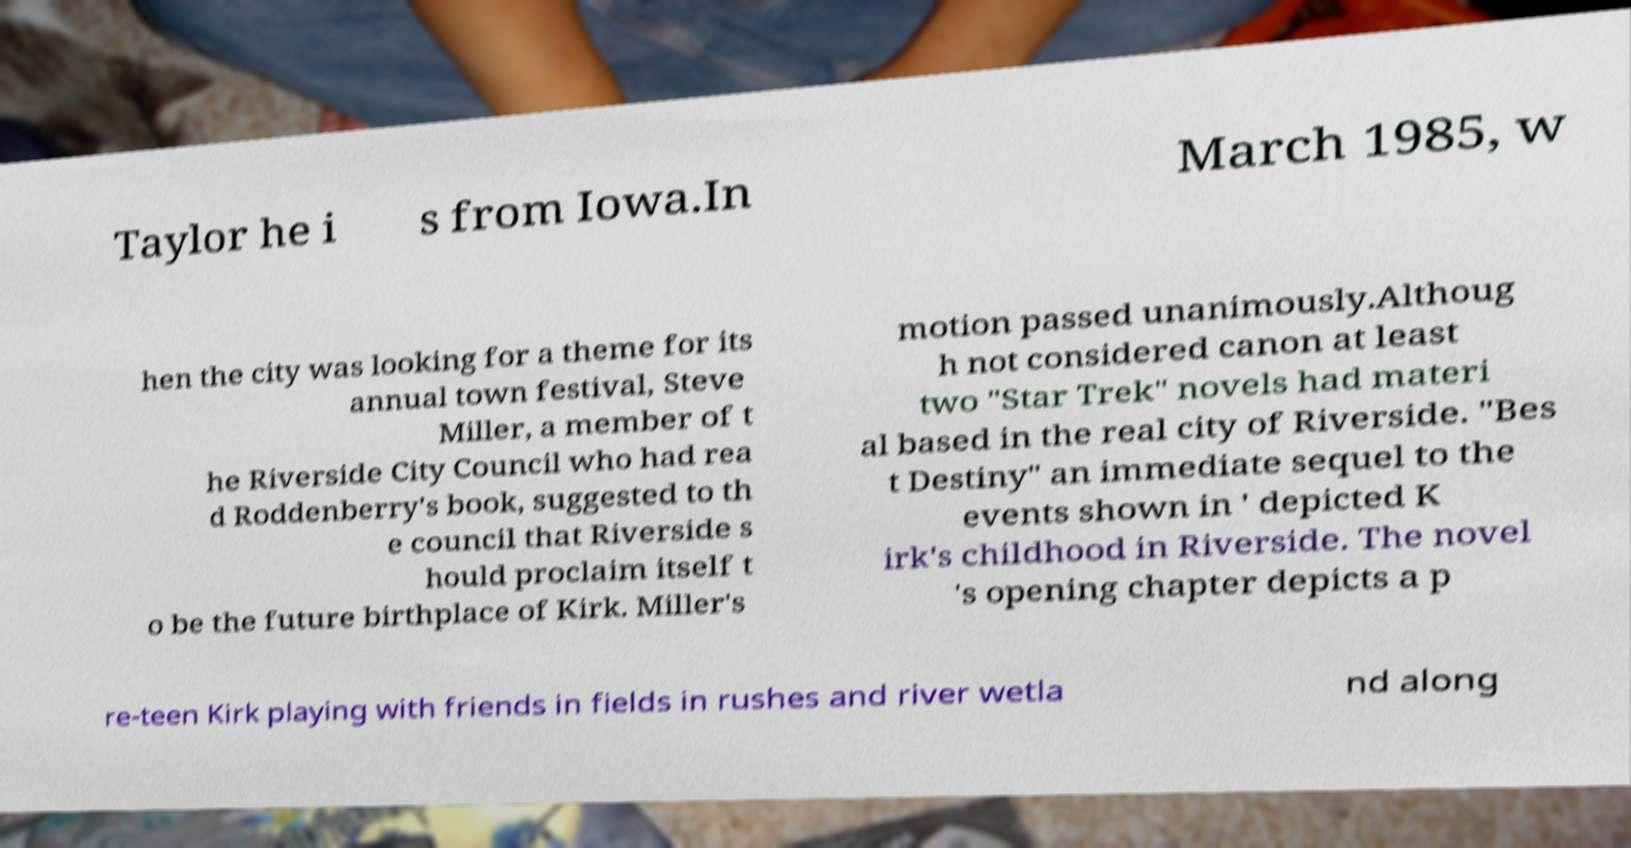Can you accurately transcribe the text from the provided image for me? Taylor he i s from Iowa.In March 1985, w hen the city was looking for a theme for its annual town festival, Steve Miller, a member of t he Riverside City Council who had rea d Roddenberry's book, suggested to th e council that Riverside s hould proclaim itself t o be the future birthplace of Kirk. Miller's motion passed unanimously.Althoug h not considered canon at least two "Star Trek" novels had materi al based in the real city of Riverside. "Bes t Destiny" an immediate sequel to the events shown in ' depicted K irk's childhood in Riverside. The novel 's opening chapter depicts a p re-teen Kirk playing with friends in fields in rushes and river wetla nd along 